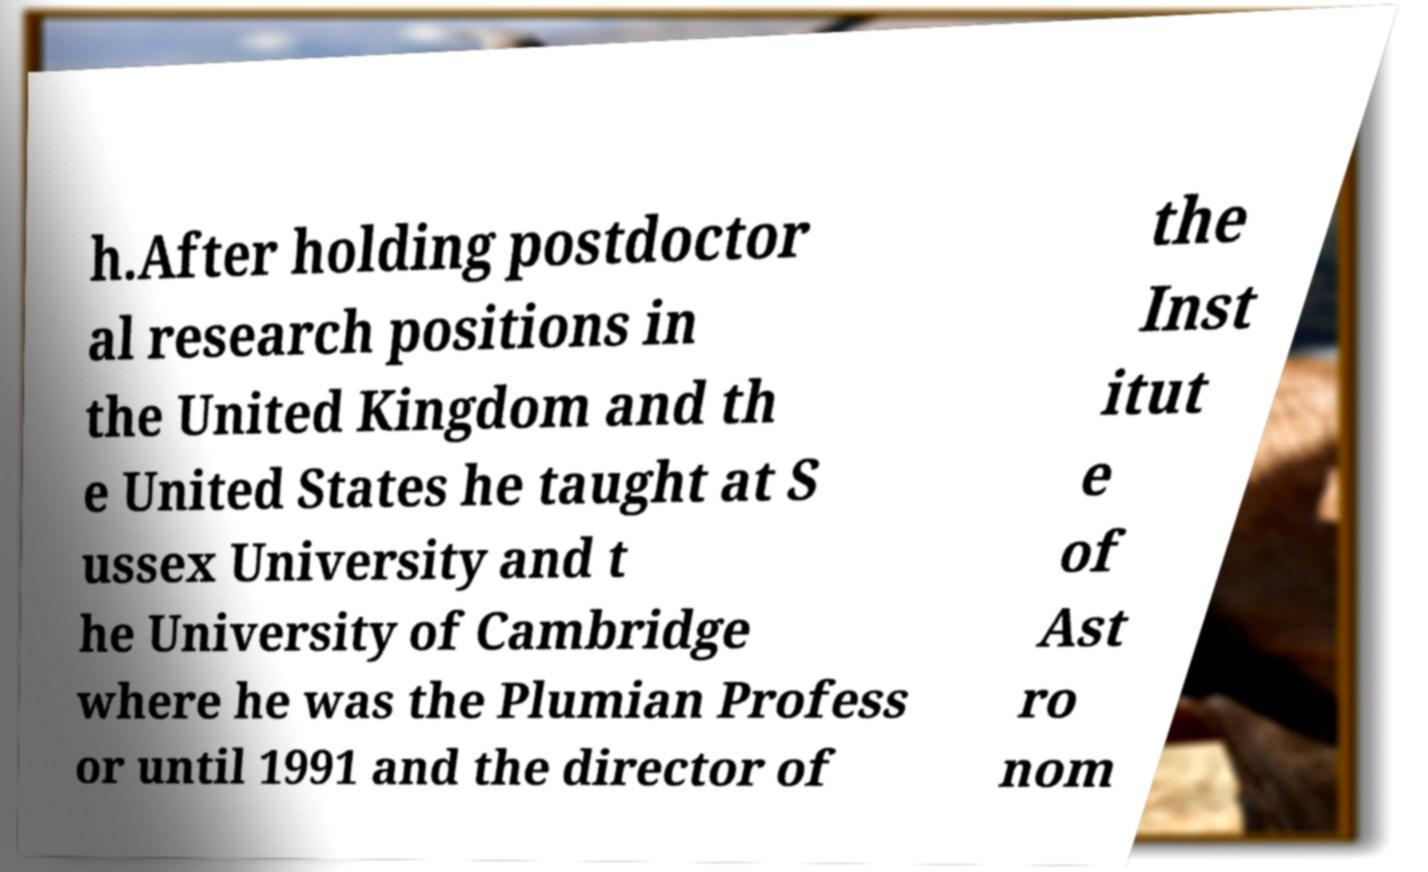There's text embedded in this image that I need extracted. Can you transcribe it verbatim? h.After holding postdoctor al research positions in the United Kingdom and th e United States he taught at S ussex University and t he University of Cambridge where he was the Plumian Profess or until 1991 and the director of the Inst itut e of Ast ro nom 